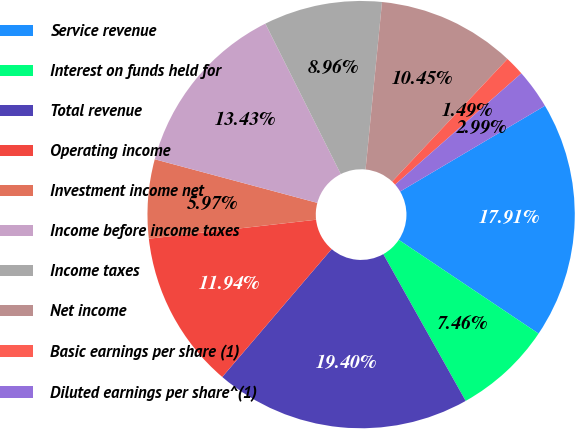Convert chart to OTSL. <chart><loc_0><loc_0><loc_500><loc_500><pie_chart><fcel>Service revenue<fcel>Interest on funds held for<fcel>Total revenue<fcel>Operating income<fcel>Investment income net<fcel>Income before income taxes<fcel>Income taxes<fcel>Net income<fcel>Basic earnings per share (1)<fcel>Diluted earnings per share^(1)<nl><fcel>17.91%<fcel>7.46%<fcel>19.4%<fcel>11.94%<fcel>5.97%<fcel>13.43%<fcel>8.96%<fcel>10.45%<fcel>1.49%<fcel>2.99%<nl></chart> 